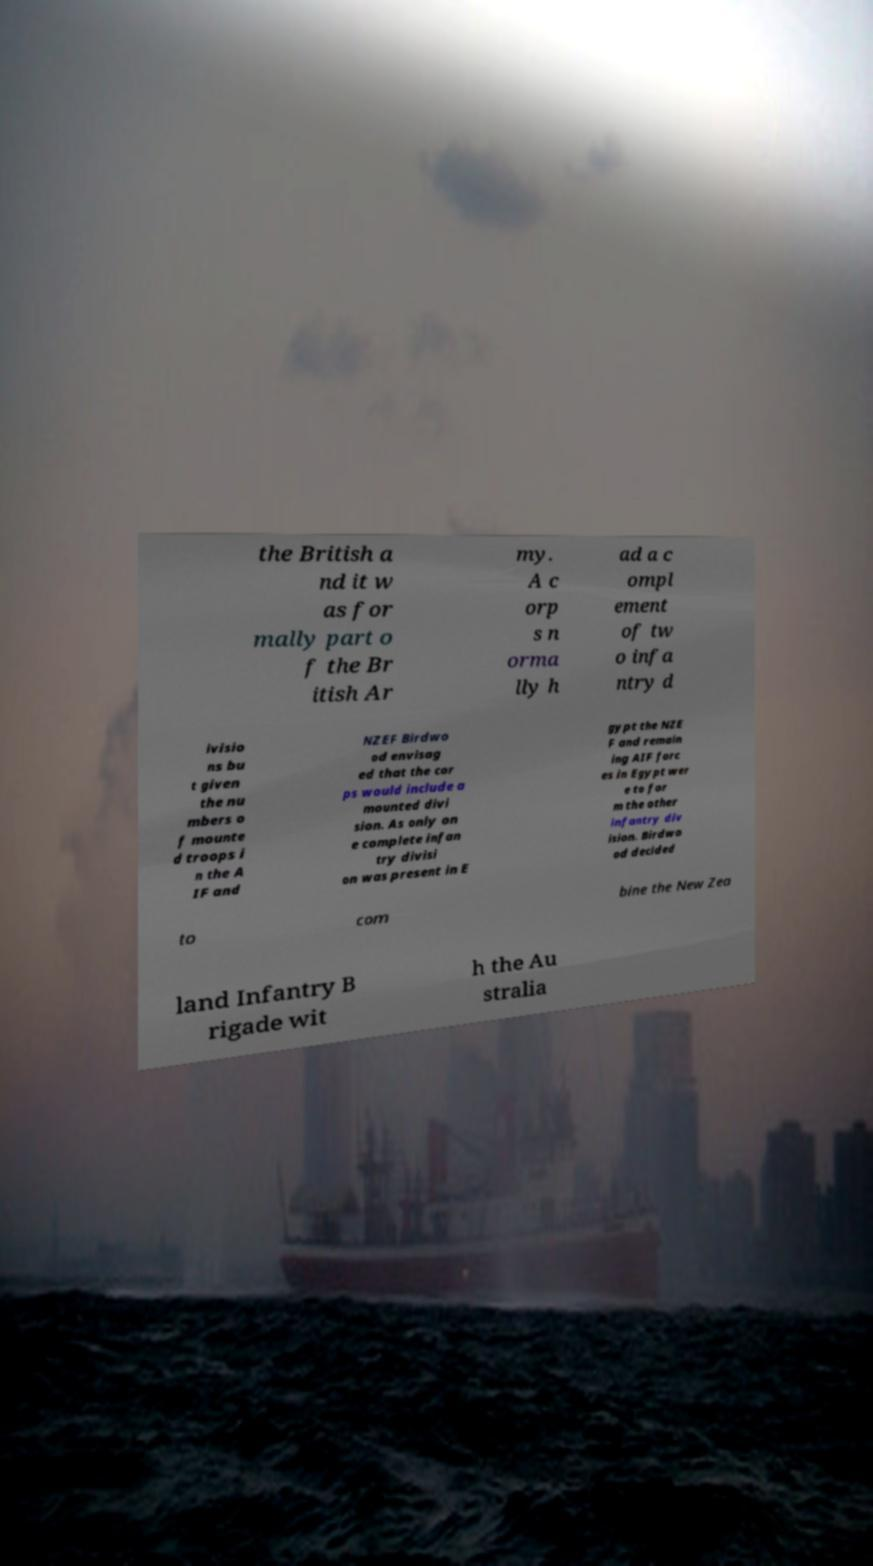Could you extract and type out the text from this image? the British a nd it w as for mally part o f the Br itish Ar my. A c orp s n orma lly h ad a c ompl ement of tw o infa ntry d ivisio ns bu t given the nu mbers o f mounte d troops i n the A IF and NZEF Birdwo od envisag ed that the cor ps would include a mounted divi sion. As only on e complete infan try divisi on was present in E gypt the NZE F and remain ing AIF forc es in Egypt wer e to for m the other infantry div ision. Birdwo od decided to com bine the New Zea land Infantry B rigade wit h the Au stralia 